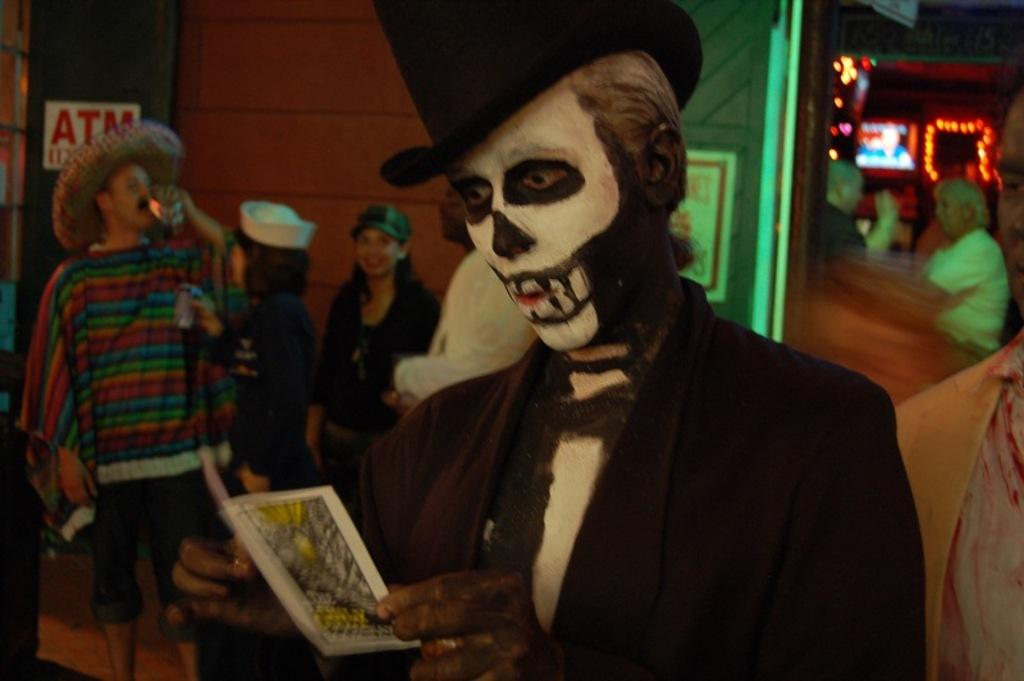What is the man in the image wearing? The man is wearing a costume in the image. What is the man holding in the image? The man is holding a card in the image. Can you describe the background of the image? There is a group of people visible on the backside of the image, and there is a wall visible in the image. What other elements can be seen in the image? There are lights and sign boards with text in the image. What type of soup is being served to the family in the image? There is no family or soup present in the image. 